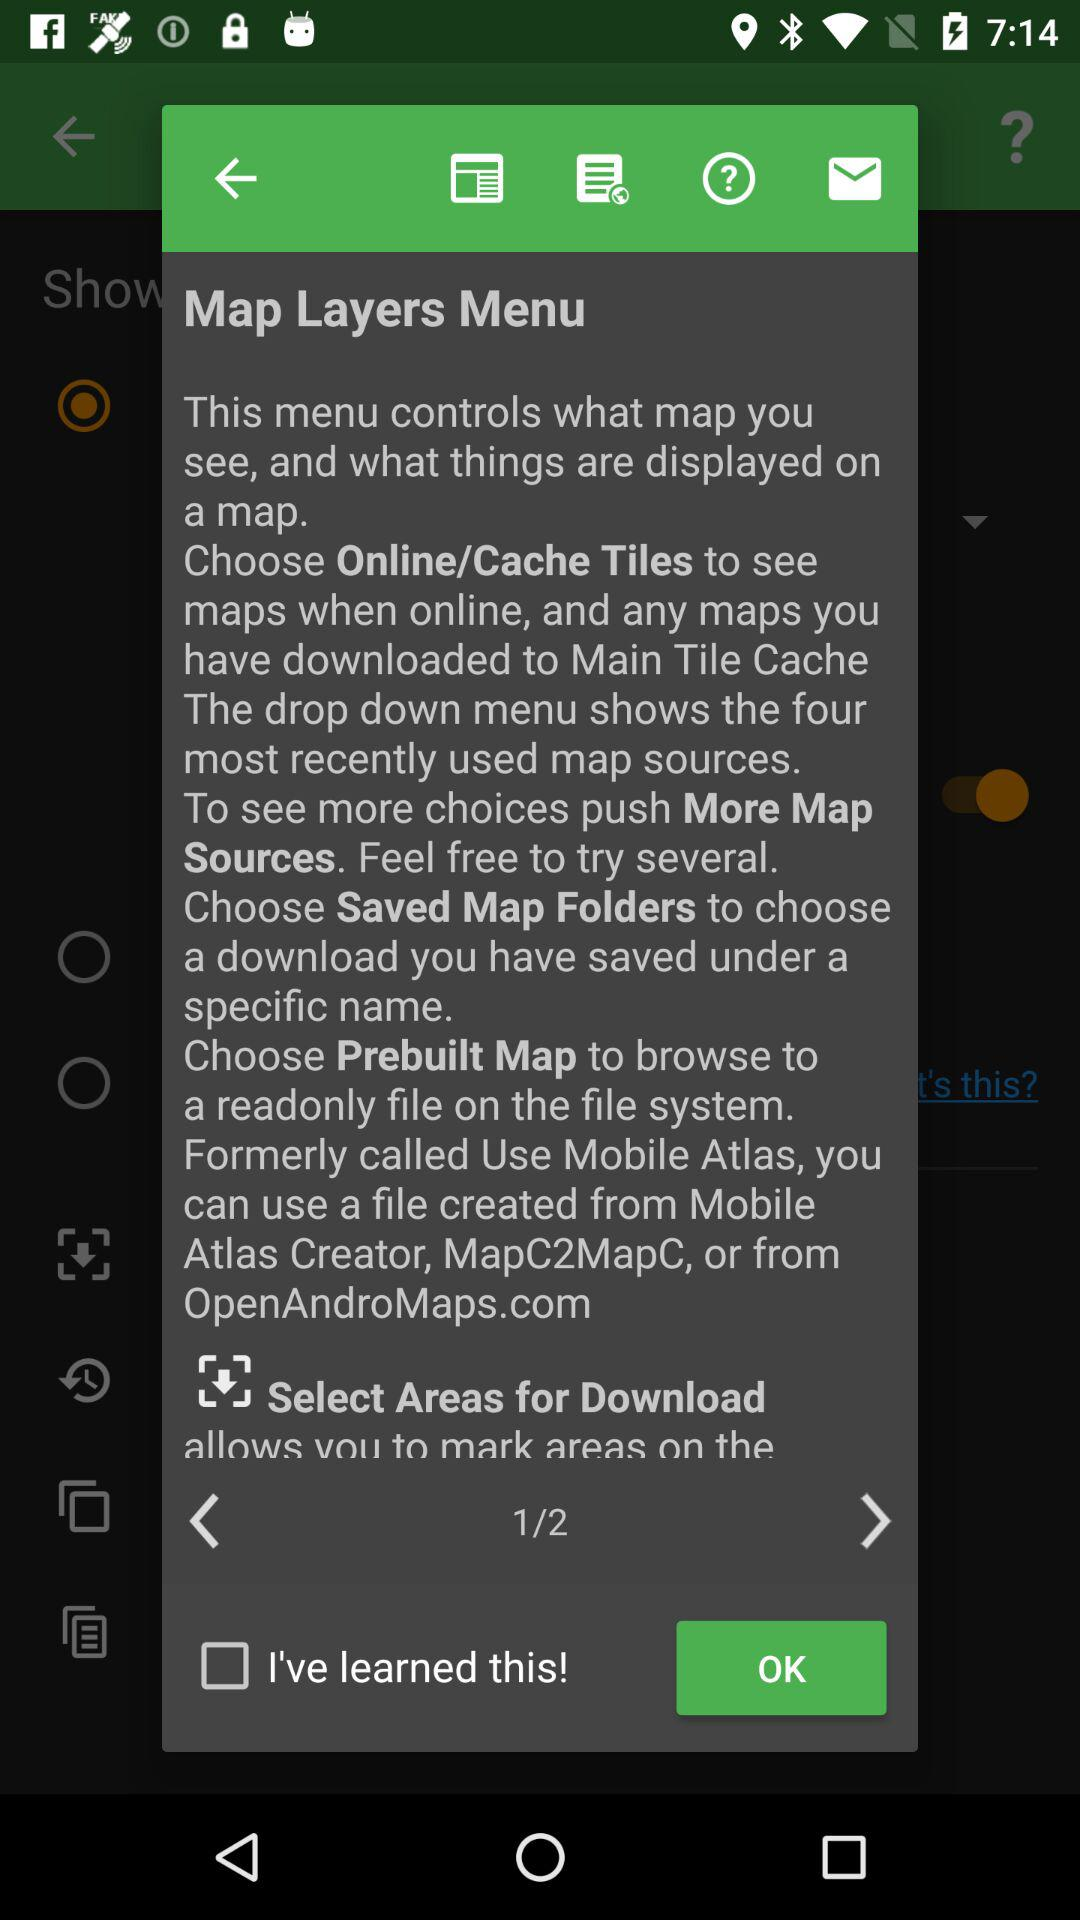How many pages in total are there? There are 2 pages. 